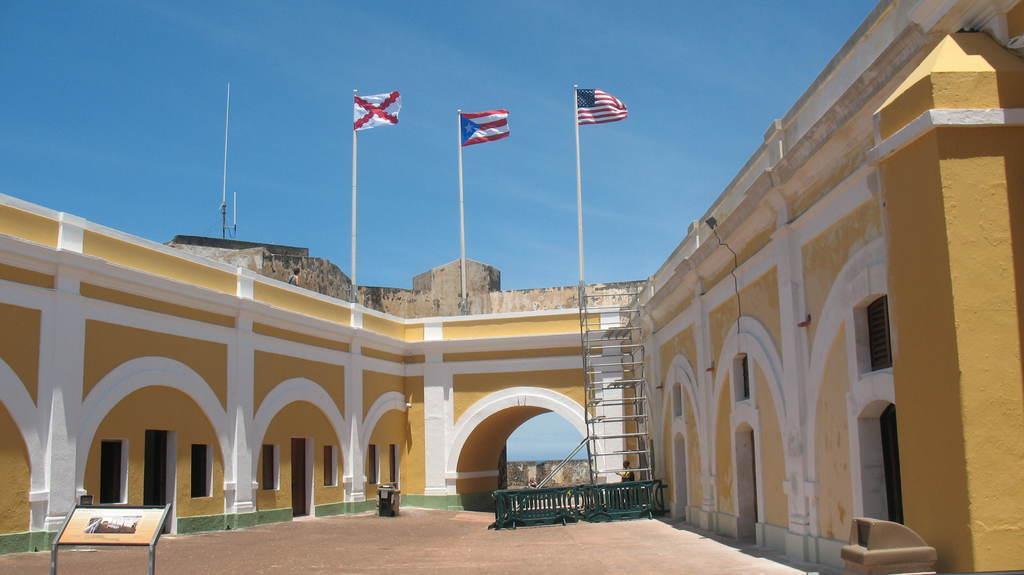Describe this image in one or two sentences. In this image there is a building, at the top of the building there are three flags and there are few objects on the surface, there is a metal structure. In the background there is the sky. 